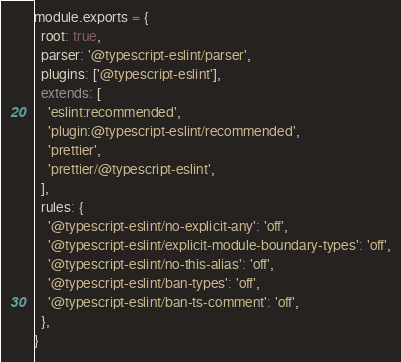Convert code to text. <code><loc_0><loc_0><loc_500><loc_500><_JavaScript_>module.exports = {
  root: true,
  parser: '@typescript-eslint/parser',
  plugins: ['@typescript-eslint'],
  extends: [
    'eslint:recommended',
    'plugin:@typescript-eslint/recommended',
    'prettier',
    'prettier/@typescript-eslint',
  ],
  rules: {
    '@typescript-eslint/no-explicit-any': 'off',
    '@typescript-eslint/explicit-module-boundary-types': 'off',
    '@typescript-eslint/no-this-alias': 'off',
    '@typescript-eslint/ban-types': 'off',
    '@typescript-eslint/ban-ts-comment': 'off',
  },
}
</code> 